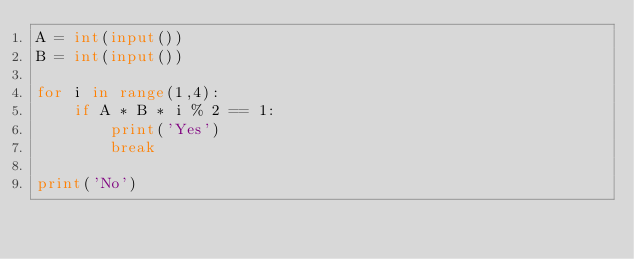<code> <loc_0><loc_0><loc_500><loc_500><_Python_>A = int(input())
B = int(input())

for i in range(1,4):
    if A * B * i % 2 == 1:
        print('Yes')
        break

print('No')</code> 